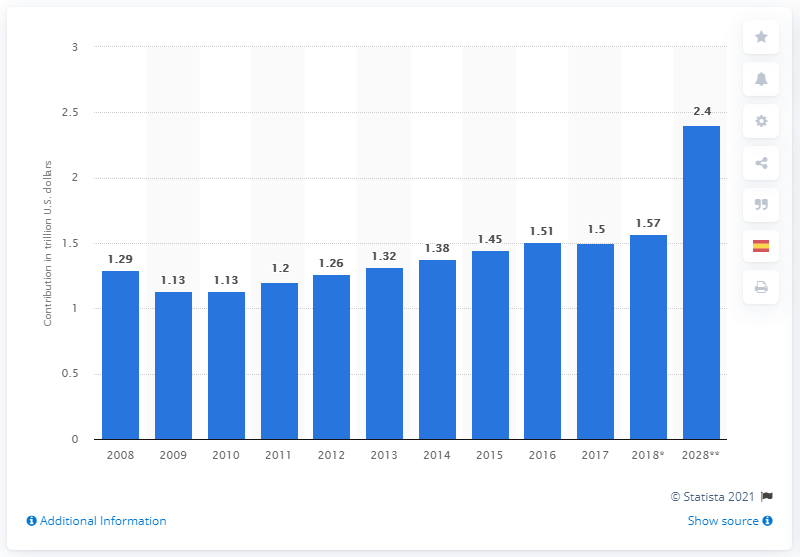Draw attention to some important aspects in this diagram. According to projections, travel and tourism were expected to contribute 2.4% to the economy of the United States in 2028. 